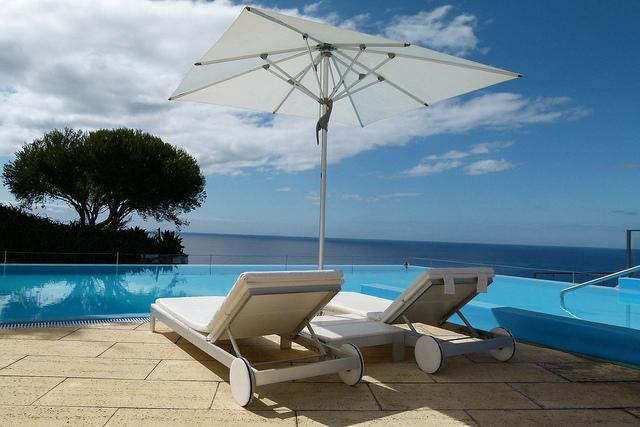What would a person be doing here? relaxing 